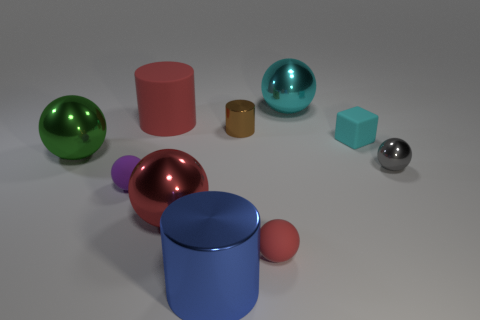There is a cyan object in front of the large thing that is behind the red object that is behind the red metal sphere; what is its material?
Give a very brief answer. Rubber. What is the cylinder in front of the small sphere on the left side of the red matte ball made of?
Offer a terse response. Metal. Is the number of tiny red spheres that are behind the small shiny cylinder less than the number of green objects?
Offer a very short reply. Yes. There is a red rubber object that is to the left of the big blue metallic cylinder; what is its shape?
Provide a short and direct response. Cylinder. There is a blue object; is it the same size as the shiny cylinder on the right side of the large blue shiny object?
Your answer should be very brief. No. Are there any yellow cubes that have the same material as the gray ball?
Offer a terse response. No. What number of cylinders are small purple objects or small red objects?
Ensure brevity in your answer.  0. Is there a small cyan rubber thing on the left side of the big object behind the big red rubber cylinder?
Make the answer very short. No. Is the number of small purple balls less than the number of blue metal spheres?
Your response must be concise. No. What number of purple objects are the same shape as the brown metal object?
Keep it short and to the point. 0. 